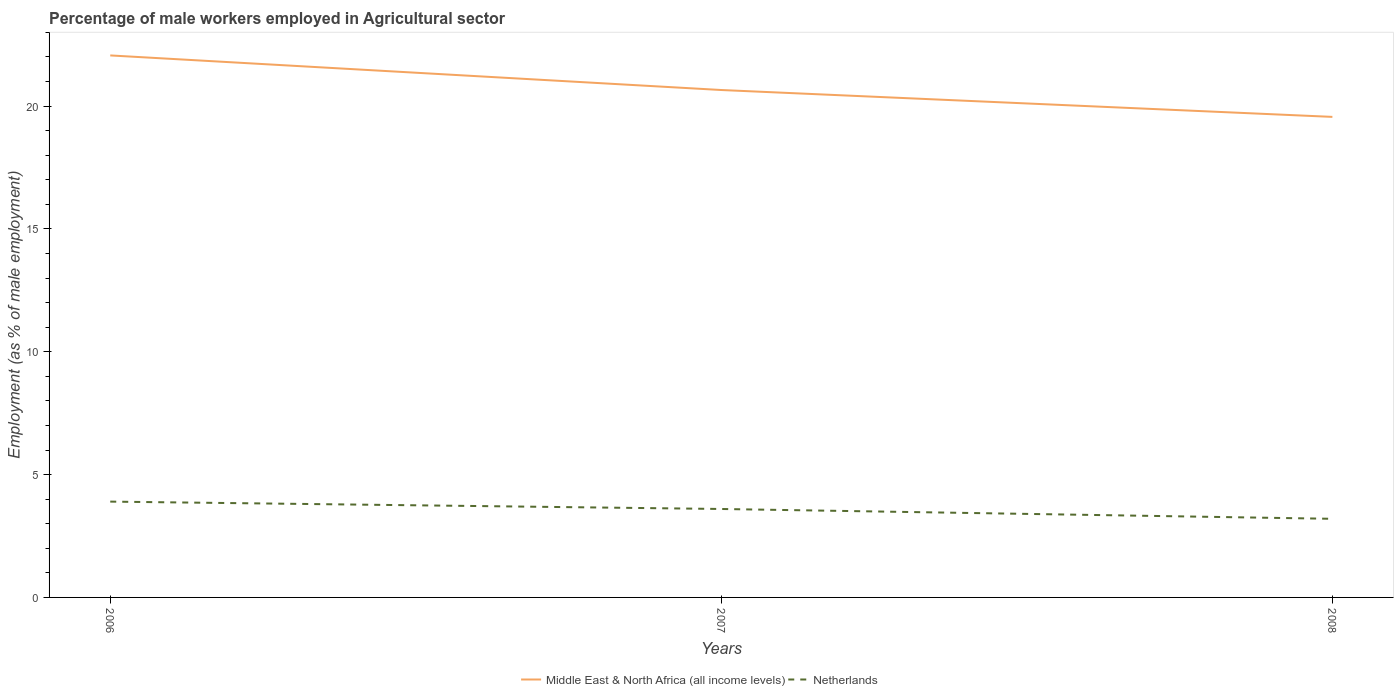How many different coloured lines are there?
Offer a terse response. 2. Is the number of lines equal to the number of legend labels?
Provide a short and direct response. Yes. Across all years, what is the maximum percentage of male workers employed in Agricultural sector in Netherlands?
Ensure brevity in your answer.  3.2. In which year was the percentage of male workers employed in Agricultural sector in Netherlands maximum?
Provide a short and direct response. 2008. What is the total percentage of male workers employed in Agricultural sector in Netherlands in the graph?
Your answer should be compact. 0.4. What is the difference between the highest and the second highest percentage of male workers employed in Agricultural sector in Netherlands?
Your answer should be very brief. 0.7. What is the difference between the highest and the lowest percentage of male workers employed in Agricultural sector in Middle East & North Africa (all income levels)?
Make the answer very short. 1. Is the percentage of male workers employed in Agricultural sector in Middle East & North Africa (all income levels) strictly greater than the percentage of male workers employed in Agricultural sector in Netherlands over the years?
Your answer should be very brief. No. How many lines are there?
Offer a very short reply. 2. Does the graph contain any zero values?
Offer a very short reply. No. How many legend labels are there?
Your answer should be very brief. 2. How are the legend labels stacked?
Make the answer very short. Horizontal. What is the title of the graph?
Your answer should be compact. Percentage of male workers employed in Agricultural sector. Does "China" appear as one of the legend labels in the graph?
Your answer should be compact. No. What is the label or title of the Y-axis?
Your answer should be very brief. Employment (as % of male employment). What is the Employment (as % of male employment) in Middle East & North Africa (all income levels) in 2006?
Provide a succinct answer. 22.06. What is the Employment (as % of male employment) in Netherlands in 2006?
Offer a very short reply. 3.9. What is the Employment (as % of male employment) in Middle East & North Africa (all income levels) in 2007?
Give a very brief answer. 20.65. What is the Employment (as % of male employment) in Netherlands in 2007?
Your response must be concise. 3.6. What is the Employment (as % of male employment) of Middle East & North Africa (all income levels) in 2008?
Offer a very short reply. 19.56. What is the Employment (as % of male employment) in Netherlands in 2008?
Your answer should be compact. 3.2. Across all years, what is the maximum Employment (as % of male employment) in Middle East & North Africa (all income levels)?
Keep it short and to the point. 22.06. Across all years, what is the maximum Employment (as % of male employment) of Netherlands?
Give a very brief answer. 3.9. Across all years, what is the minimum Employment (as % of male employment) of Middle East & North Africa (all income levels)?
Offer a very short reply. 19.56. Across all years, what is the minimum Employment (as % of male employment) of Netherlands?
Give a very brief answer. 3.2. What is the total Employment (as % of male employment) of Middle East & North Africa (all income levels) in the graph?
Your response must be concise. 62.28. What is the total Employment (as % of male employment) of Netherlands in the graph?
Provide a short and direct response. 10.7. What is the difference between the Employment (as % of male employment) in Middle East & North Africa (all income levels) in 2006 and that in 2007?
Your answer should be very brief. 1.41. What is the difference between the Employment (as % of male employment) in Netherlands in 2006 and that in 2007?
Your response must be concise. 0.3. What is the difference between the Employment (as % of male employment) in Middle East & North Africa (all income levels) in 2006 and that in 2008?
Ensure brevity in your answer.  2.5. What is the difference between the Employment (as % of male employment) in Middle East & North Africa (all income levels) in 2007 and that in 2008?
Your answer should be compact. 1.09. What is the difference between the Employment (as % of male employment) in Netherlands in 2007 and that in 2008?
Your answer should be compact. 0.4. What is the difference between the Employment (as % of male employment) in Middle East & North Africa (all income levels) in 2006 and the Employment (as % of male employment) in Netherlands in 2007?
Offer a very short reply. 18.46. What is the difference between the Employment (as % of male employment) of Middle East & North Africa (all income levels) in 2006 and the Employment (as % of male employment) of Netherlands in 2008?
Your answer should be compact. 18.86. What is the difference between the Employment (as % of male employment) of Middle East & North Africa (all income levels) in 2007 and the Employment (as % of male employment) of Netherlands in 2008?
Provide a short and direct response. 17.45. What is the average Employment (as % of male employment) of Middle East & North Africa (all income levels) per year?
Keep it short and to the point. 20.76. What is the average Employment (as % of male employment) in Netherlands per year?
Give a very brief answer. 3.57. In the year 2006, what is the difference between the Employment (as % of male employment) in Middle East & North Africa (all income levels) and Employment (as % of male employment) in Netherlands?
Make the answer very short. 18.16. In the year 2007, what is the difference between the Employment (as % of male employment) in Middle East & North Africa (all income levels) and Employment (as % of male employment) in Netherlands?
Provide a succinct answer. 17.05. In the year 2008, what is the difference between the Employment (as % of male employment) in Middle East & North Africa (all income levels) and Employment (as % of male employment) in Netherlands?
Keep it short and to the point. 16.36. What is the ratio of the Employment (as % of male employment) of Middle East & North Africa (all income levels) in 2006 to that in 2007?
Your answer should be compact. 1.07. What is the ratio of the Employment (as % of male employment) of Middle East & North Africa (all income levels) in 2006 to that in 2008?
Offer a very short reply. 1.13. What is the ratio of the Employment (as % of male employment) of Netherlands in 2006 to that in 2008?
Ensure brevity in your answer.  1.22. What is the ratio of the Employment (as % of male employment) in Middle East & North Africa (all income levels) in 2007 to that in 2008?
Give a very brief answer. 1.06. What is the ratio of the Employment (as % of male employment) in Netherlands in 2007 to that in 2008?
Give a very brief answer. 1.12. What is the difference between the highest and the second highest Employment (as % of male employment) in Middle East & North Africa (all income levels)?
Provide a short and direct response. 1.41. What is the difference between the highest and the lowest Employment (as % of male employment) in Middle East & North Africa (all income levels)?
Make the answer very short. 2.5. What is the difference between the highest and the lowest Employment (as % of male employment) in Netherlands?
Give a very brief answer. 0.7. 